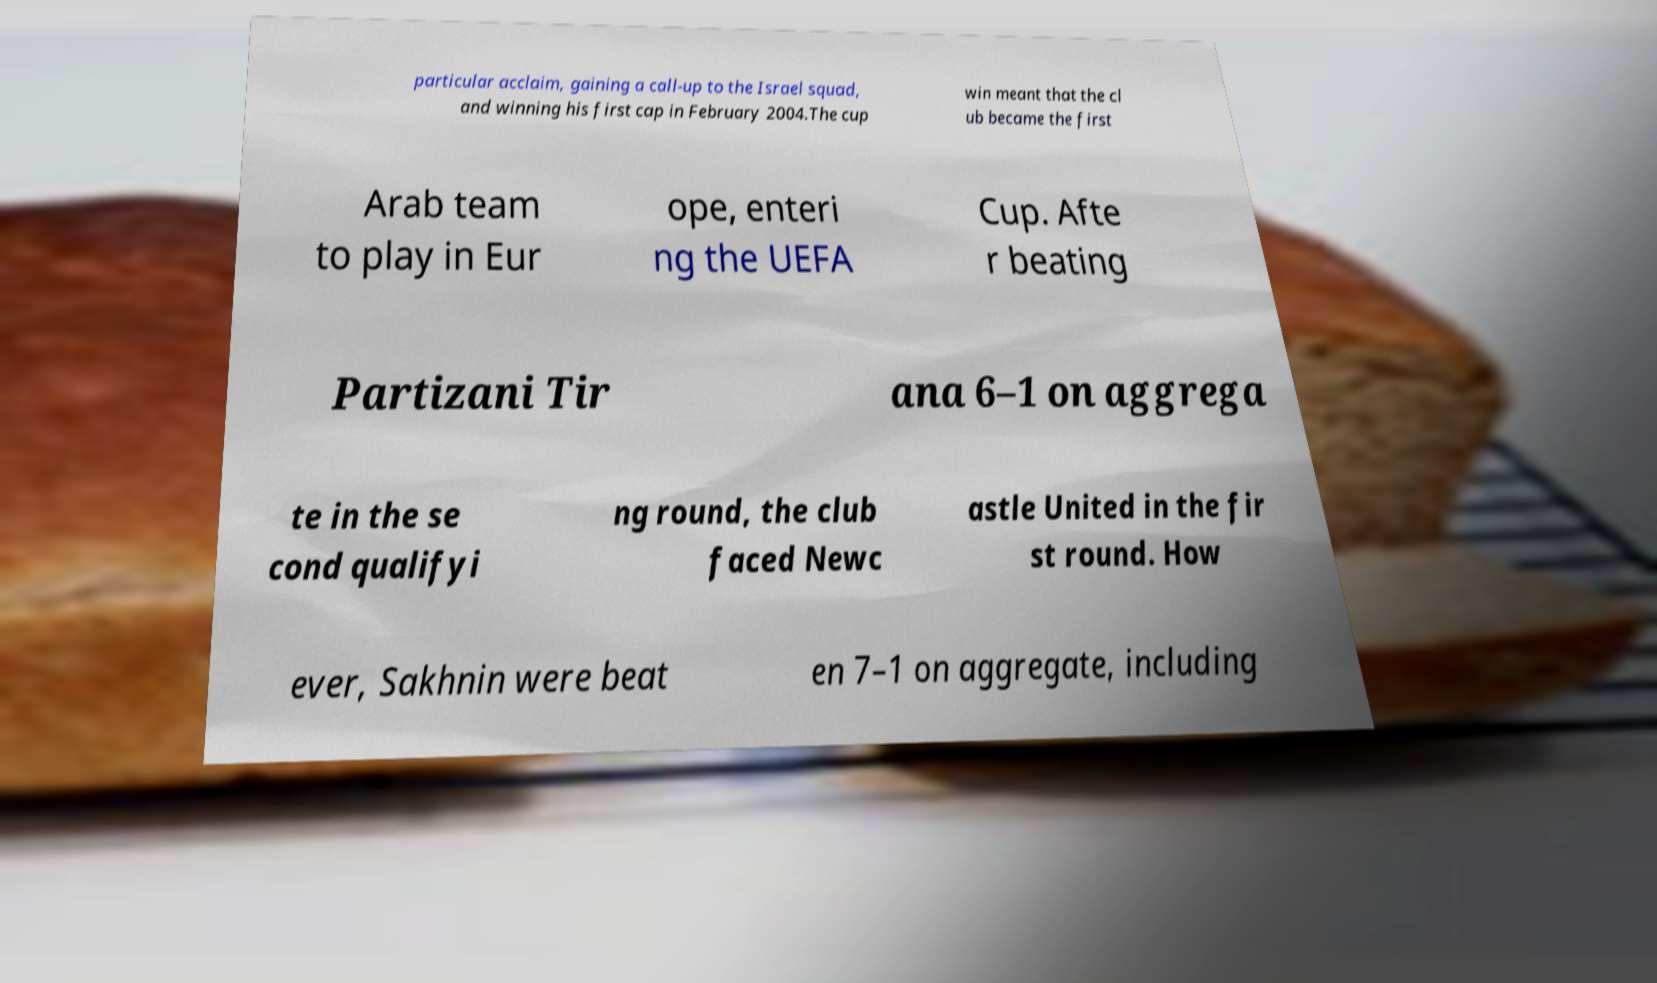Can you accurately transcribe the text from the provided image for me? particular acclaim, gaining a call-up to the Israel squad, and winning his first cap in February 2004.The cup win meant that the cl ub became the first Arab team to play in Eur ope, enteri ng the UEFA Cup. Afte r beating Partizani Tir ana 6–1 on aggrega te in the se cond qualifyi ng round, the club faced Newc astle United in the fir st round. How ever, Sakhnin were beat en 7–1 on aggregate, including 